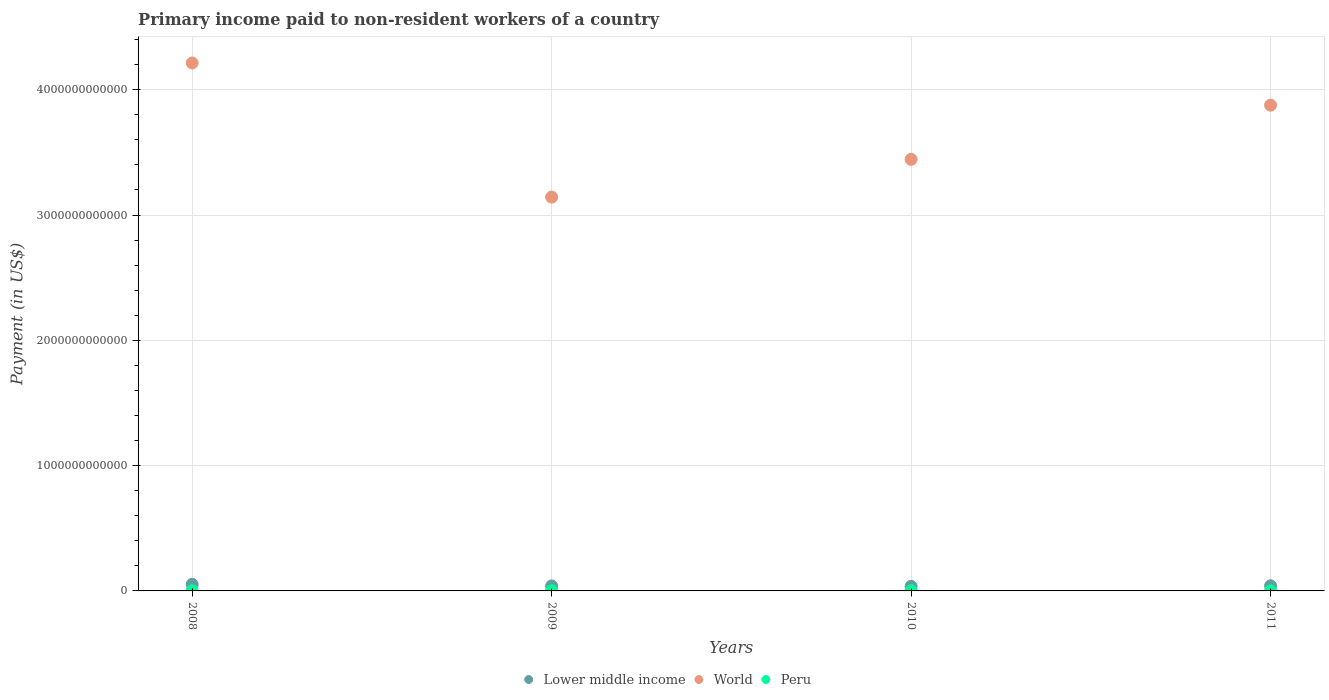What is the amount paid to workers in World in 2008?
Provide a short and direct response. 4.21e+12. Across all years, what is the maximum amount paid to workers in Peru?
Offer a terse response. 1.84e+09. Across all years, what is the minimum amount paid to workers in Peru?
Your answer should be very brief. 1.11e+09. What is the total amount paid to workers in Lower middle income in the graph?
Ensure brevity in your answer.  1.70e+11. What is the difference between the amount paid to workers in World in 2008 and that in 2009?
Your response must be concise. 1.07e+12. What is the difference between the amount paid to workers in Lower middle income in 2010 and the amount paid to workers in Peru in 2009?
Your response must be concise. 3.55e+1. What is the average amount paid to workers in Peru per year?
Keep it short and to the point. 1.37e+09. In the year 2008, what is the difference between the amount paid to workers in Peru and amount paid to workers in World?
Provide a succinct answer. -4.21e+12. In how many years, is the amount paid to workers in Peru greater than 4000000000000 US$?
Provide a succinct answer. 0. What is the ratio of the amount paid to workers in Lower middle income in 2008 to that in 2009?
Provide a succinct answer. 1.31. Is the amount paid to workers in Lower middle income in 2008 less than that in 2011?
Your answer should be very brief. No. Is the difference between the amount paid to workers in Peru in 2010 and 2011 greater than the difference between the amount paid to workers in World in 2010 and 2011?
Your response must be concise. Yes. What is the difference between the highest and the second highest amount paid to workers in Peru?
Provide a succinct answer. 4.37e+08. What is the difference between the highest and the lowest amount paid to workers in Lower middle income?
Give a very brief answer. 1.54e+1. Is the amount paid to workers in Lower middle income strictly greater than the amount paid to workers in World over the years?
Provide a short and direct response. No. How many years are there in the graph?
Make the answer very short. 4. What is the difference between two consecutive major ticks on the Y-axis?
Make the answer very short. 1.00e+12. Are the values on the major ticks of Y-axis written in scientific E-notation?
Keep it short and to the point. No. Does the graph contain grids?
Make the answer very short. Yes. Where does the legend appear in the graph?
Keep it short and to the point. Bottom center. How many legend labels are there?
Give a very brief answer. 3. How are the legend labels stacked?
Provide a short and direct response. Horizontal. What is the title of the graph?
Offer a terse response. Primary income paid to non-resident workers of a country. Does "Belize" appear as one of the legend labels in the graph?
Give a very brief answer. No. What is the label or title of the Y-axis?
Offer a very short reply. Payment (in US$). What is the Payment (in US$) in Lower middle income in 2008?
Offer a very short reply. 5.23e+1. What is the Payment (in US$) in World in 2008?
Make the answer very short. 4.21e+12. What is the Payment (in US$) of Peru in 2008?
Give a very brief answer. 1.84e+09. What is the Payment (in US$) of Lower middle income in 2009?
Your answer should be compact. 3.98e+1. What is the Payment (in US$) of World in 2009?
Offer a very short reply. 3.14e+12. What is the Payment (in US$) of Peru in 2009?
Offer a terse response. 1.40e+09. What is the Payment (in US$) of Lower middle income in 2010?
Offer a very short reply. 3.69e+1. What is the Payment (in US$) of World in 2010?
Your response must be concise. 3.44e+12. What is the Payment (in US$) of Peru in 2010?
Your answer should be compact. 1.15e+09. What is the Payment (in US$) in Lower middle income in 2011?
Your answer should be compact. 4.10e+1. What is the Payment (in US$) of World in 2011?
Your response must be concise. 3.88e+12. What is the Payment (in US$) of Peru in 2011?
Provide a succinct answer. 1.11e+09. Across all years, what is the maximum Payment (in US$) of Lower middle income?
Ensure brevity in your answer.  5.23e+1. Across all years, what is the maximum Payment (in US$) of World?
Your answer should be compact. 4.21e+12. Across all years, what is the maximum Payment (in US$) in Peru?
Give a very brief answer. 1.84e+09. Across all years, what is the minimum Payment (in US$) of Lower middle income?
Offer a terse response. 3.69e+1. Across all years, what is the minimum Payment (in US$) in World?
Provide a succinct answer. 3.14e+12. Across all years, what is the minimum Payment (in US$) of Peru?
Your answer should be very brief. 1.11e+09. What is the total Payment (in US$) in Lower middle income in the graph?
Your response must be concise. 1.70e+11. What is the total Payment (in US$) of World in the graph?
Offer a terse response. 1.47e+13. What is the total Payment (in US$) of Peru in the graph?
Provide a succinct answer. 5.50e+09. What is the difference between the Payment (in US$) in Lower middle income in 2008 and that in 2009?
Make the answer very short. 1.25e+1. What is the difference between the Payment (in US$) in World in 2008 and that in 2009?
Keep it short and to the point. 1.07e+12. What is the difference between the Payment (in US$) in Peru in 2008 and that in 2009?
Offer a very short reply. 4.37e+08. What is the difference between the Payment (in US$) of Lower middle income in 2008 and that in 2010?
Keep it short and to the point. 1.54e+1. What is the difference between the Payment (in US$) of World in 2008 and that in 2010?
Offer a very short reply. 7.69e+11. What is the difference between the Payment (in US$) of Peru in 2008 and that in 2010?
Your answer should be compact. 6.88e+08. What is the difference between the Payment (in US$) in Lower middle income in 2008 and that in 2011?
Make the answer very short. 1.12e+1. What is the difference between the Payment (in US$) in World in 2008 and that in 2011?
Provide a succinct answer. 3.37e+11. What is the difference between the Payment (in US$) of Peru in 2008 and that in 2011?
Provide a succinct answer. 7.26e+08. What is the difference between the Payment (in US$) in Lower middle income in 2009 and that in 2010?
Your response must be concise. 2.89e+09. What is the difference between the Payment (in US$) of World in 2009 and that in 2010?
Your answer should be very brief. -3.01e+11. What is the difference between the Payment (in US$) of Peru in 2009 and that in 2010?
Offer a terse response. 2.51e+08. What is the difference between the Payment (in US$) in Lower middle income in 2009 and that in 2011?
Your response must be concise. -1.26e+09. What is the difference between the Payment (in US$) in World in 2009 and that in 2011?
Offer a terse response. -7.34e+11. What is the difference between the Payment (in US$) in Peru in 2009 and that in 2011?
Your response must be concise. 2.89e+08. What is the difference between the Payment (in US$) in Lower middle income in 2010 and that in 2011?
Your answer should be compact. -4.15e+09. What is the difference between the Payment (in US$) in World in 2010 and that in 2011?
Your answer should be very brief. -4.33e+11. What is the difference between the Payment (in US$) of Peru in 2010 and that in 2011?
Provide a succinct answer. 3.73e+07. What is the difference between the Payment (in US$) of Lower middle income in 2008 and the Payment (in US$) of World in 2009?
Ensure brevity in your answer.  -3.09e+12. What is the difference between the Payment (in US$) of Lower middle income in 2008 and the Payment (in US$) of Peru in 2009?
Your answer should be very brief. 5.09e+1. What is the difference between the Payment (in US$) of World in 2008 and the Payment (in US$) of Peru in 2009?
Your response must be concise. 4.21e+12. What is the difference between the Payment (in US$) in Lower middle income in 2008 and the Payment (in US$) in World in 2010?
Ensure brevity in your answer.  -3.39e+12. What is the difference between the Payment (in US$) of Lower middle income in 2008 and the Payment (in US$) of Peru in 2010?
Your answer should be compact. 5.11e+1. What is the difference between the Payment (in US$) of World in 2008 and the Payment (in US$) of Peru in 2010?
Provide a short and direct response. 4.21e+12. What is the difference between the Payment (in US$) of Lower middle income in 2008 and the Payment (in US$) of World in 2011?
Provide a succinct answer. -3.82e+12. What is the difference between the Payment (in US$) in Lower middle income in 2008 and the Payment (in US$) in Peru in 2011?
Keep it short and to the point. 5.12e+1. What is the difference between the Payment (in US$) in World in 2008 and the Payment (in US$) in Peru in 2011?
Your answer should be compact. 4.21e+12. What is the difference between the Payment (in US$) in Lower middle income in 2009 and the Payment (in US$) in World in 2010?
Your response must be concise. -3.40e+12. What is the difference between the Payment (in US$) in Lower middle income in 2009 and the Payment (in US$) in Peru in 2010?
Make the answer very short. 3.86e+1. What is the difference between the Payment (in US$) in World in 2009 and the Payment (in US$) in Peru in 2010?
Keep it short and to the point. 3.14e+12. What is the difference between the Payment (in US$) of Lower middle income in 2009 and the Payment (in US$) of World in 2011?
Provide a short and direct response. -3.84e+12. What is the difference between the Payment (in US$) in Lower middle income in 2009 and the Payment (in US$) in Peru in 2011?
Keep it short and to the point. 3.87e+1. What is the difference between the Payment (in US$) in World in 2009 and the Payment (in US$) in Peru in 2011?
Provide a succinct answer. 3.14e+12. What is the difference between the Payment (in US$) of Lower middle income in 2010 and the Payment (in US$) of World in 2011?
Offer a very short reply. -3.84e+12. What is the difference between the Payment (in US$) of Lower middle income in 2010 and the Payment (in US$) of Peru in 2011?
Give a very brief answer. 3.58e+1. What is the difference between the Payment (in US$) in World in 2010 and the Payment (in US$) in Peru in 2011?
Your answer should be very brief. 3.44e+12. What is the average Payment (in US$) of Lower middle income per year?
Keep it short and to the point. 4.25e+1. What is the average Payment (in US$) of World per year?
Your answer should be compact. 3.67e+12. What is the average Payment (in US$) of Peru per year?
Keep it short and to the point. 1.37e+09. In the year 2008, what is the difference between the Payment (in US$) in Lower middle income and Payment (in US$) in World?
Keep it short and to the point. -4.16e+12. In the year 2008, what is the difference between the Payment (in US$) of Lower middle income and Payment (in US$) of Peru?
Give a very brief answer. 5.04e+1. In the year 2008, what is the difference between the Payment (in US$) in World and Payment (in US$) in Peru?
Keep it short and to the point. 4.21e+12. In the year 2009, what is the difference between the Payment (in US$) in Lower middle income and Payment (in US$) in World?
Your answer should be compact. -3.10e+12. In the year 2009, what is the difference between the Payment (in US$) in Lower middle income and Payment (in US$) in Peru?
Ensure brevity in your answer.  3.84e+1. In the year 2009, what is the difference between the Payment (in US$) in World and Payment (in US$) in Peru?
Provide a succinct answer. 3.14e+12. In the year 2010, what is the difference between the Payment (in US$) of Lower middle income and Payment (in US$) of World?
Make the answer very short. -3.41e+12. In the year 2010, what is the difference between the Payment (in US$) in Lower middle income and Payment (in US$) in Peru?
Provide a succinct answer. 3.57e+1. In the year 2010, what is the difference between the Payment (in US$) of World and Payment (in US$) of Peru?
Your response must be concise. 3.44e+12. In the year 2011, what is the difference between the Payment (in US$) of Lower middle income and Payment (in US$) of World?
Give a very brief answer. -3.84e+12. In the year 2011, what is the difference between the Payment (in US$) in Lower middle income and Payment (in US$) in Peru?
Give a very brief answer. 3.99e+1. In the year 2011, what is the difference between the Payment (in US$) in World and Payment (in US$) in Peru?
Your response must be concise. 3.88e+12. What is the ratio of the Payment (in US$) of Lower middle income in 2008 to that in 2009?
Your answer should be very brief. 1.31. What is the ratio of the Payment (in US$) in World in 2008 to that in 2009?
Make the answer very short. 1.34. What is the ratio of the Payment (in US$) of Peru in 2008 to that in 2009?
Ensure brevity in your answer.  1.31. What is the ratio of the Payment (in US$) in Lower middle income in 2008 to that in 2010?
Give a very brief answer. 1.42. What is the ratio of the Payment (in US$) of World in 2008 to that in 2010?
Provide a short and direct response. 1.22. What is the ratio of the Payment (in US$) in Peru in 2008 to that in 2010?
Provide a succinct answer. 1.6. What is the ratio of the Payment (in US$) in Lower middle income in 2008 to that in 2011?
Your answer should be very brief. 1.27. What is the ratio of the Payment (in US$) of World in 2008 to that in 2011?
Provide a short and direct response. 1.09. What is the ratio of the Payment (in US$) of Peru in 2008 to that in 2011?
Your response must be concise. 1.65. What is the ratio of the Payment (in US$) in Lower middle income in 2009 to that in 2010?
Your answer should be very brief. 1.08. What is the ratio of the Payment (in US$) of World in 2009 to that in 2010?
Your response must be concise. 0.91. What is the ratio of the Payment (in US$) in Peru in 2009 to that in 2010?
Ensure brevity in your answer.  1.22. What is the ratio of the Payment (in US$) of Lower middle income in 2009 to that in 2011?
Your response must be concise. 0.97. What is the ratio of the Payment (in US$) of World in 2009 to that in 2011?
Offer a terse response. 0.81. What is the ratio of the Payment (in US$) of Peru in 2009 to that in 2011?
Ensure brevity in your answer.  1.26. What is the ratio of the Payment (in US$) in Lower middle income in 2010 to that in 2011?
Offer a very short reply. 0.9. What is the ratio of the Payment (in US$) in World in 2010 to that in 2011?
Provide a succinct answer. 0.89. What is the ratio of the Payment (in US$) of Peru in 2010 to that in 2011?
Offer a very short reply. 1.03. What is the difference between the highest and the second highest Payment (in US$) of Lower middle income?
Make the answer very short. 1.12e+1. What is the difference between the highest and the second highest Payment (in US$) of World?
Give a very brief answer. 3.37e+11. What is the difference between the highest and the second highest Payment (in US$) in Peru?
Provide a short and direct response. 4.37e+08. What is the difference between the highest and the lowest Payment (in US$) in Lower middle income?
Your answer should be compact. 1.54e+1. What is the difference between the highest and the lowest Payment (in US$) in World?
Keep it short and to the point. 1.07e+12. What is the difference between the highest and the lowest Payment (in US$) of Peru?
Ensure brevity in your answer.  7.26e+08. 